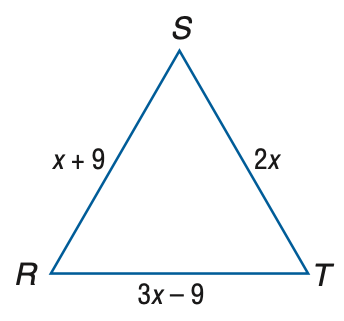Answer the mathemtical geometry problem and directly provide the correct option letter.
Question: Find the measure of R S of equilateral triangle R S T if R S = x + 9, S T = 2 x, and R T = 3 x - 9.
Choices: A: 6 B: 9 C: 12 D: 18 D 